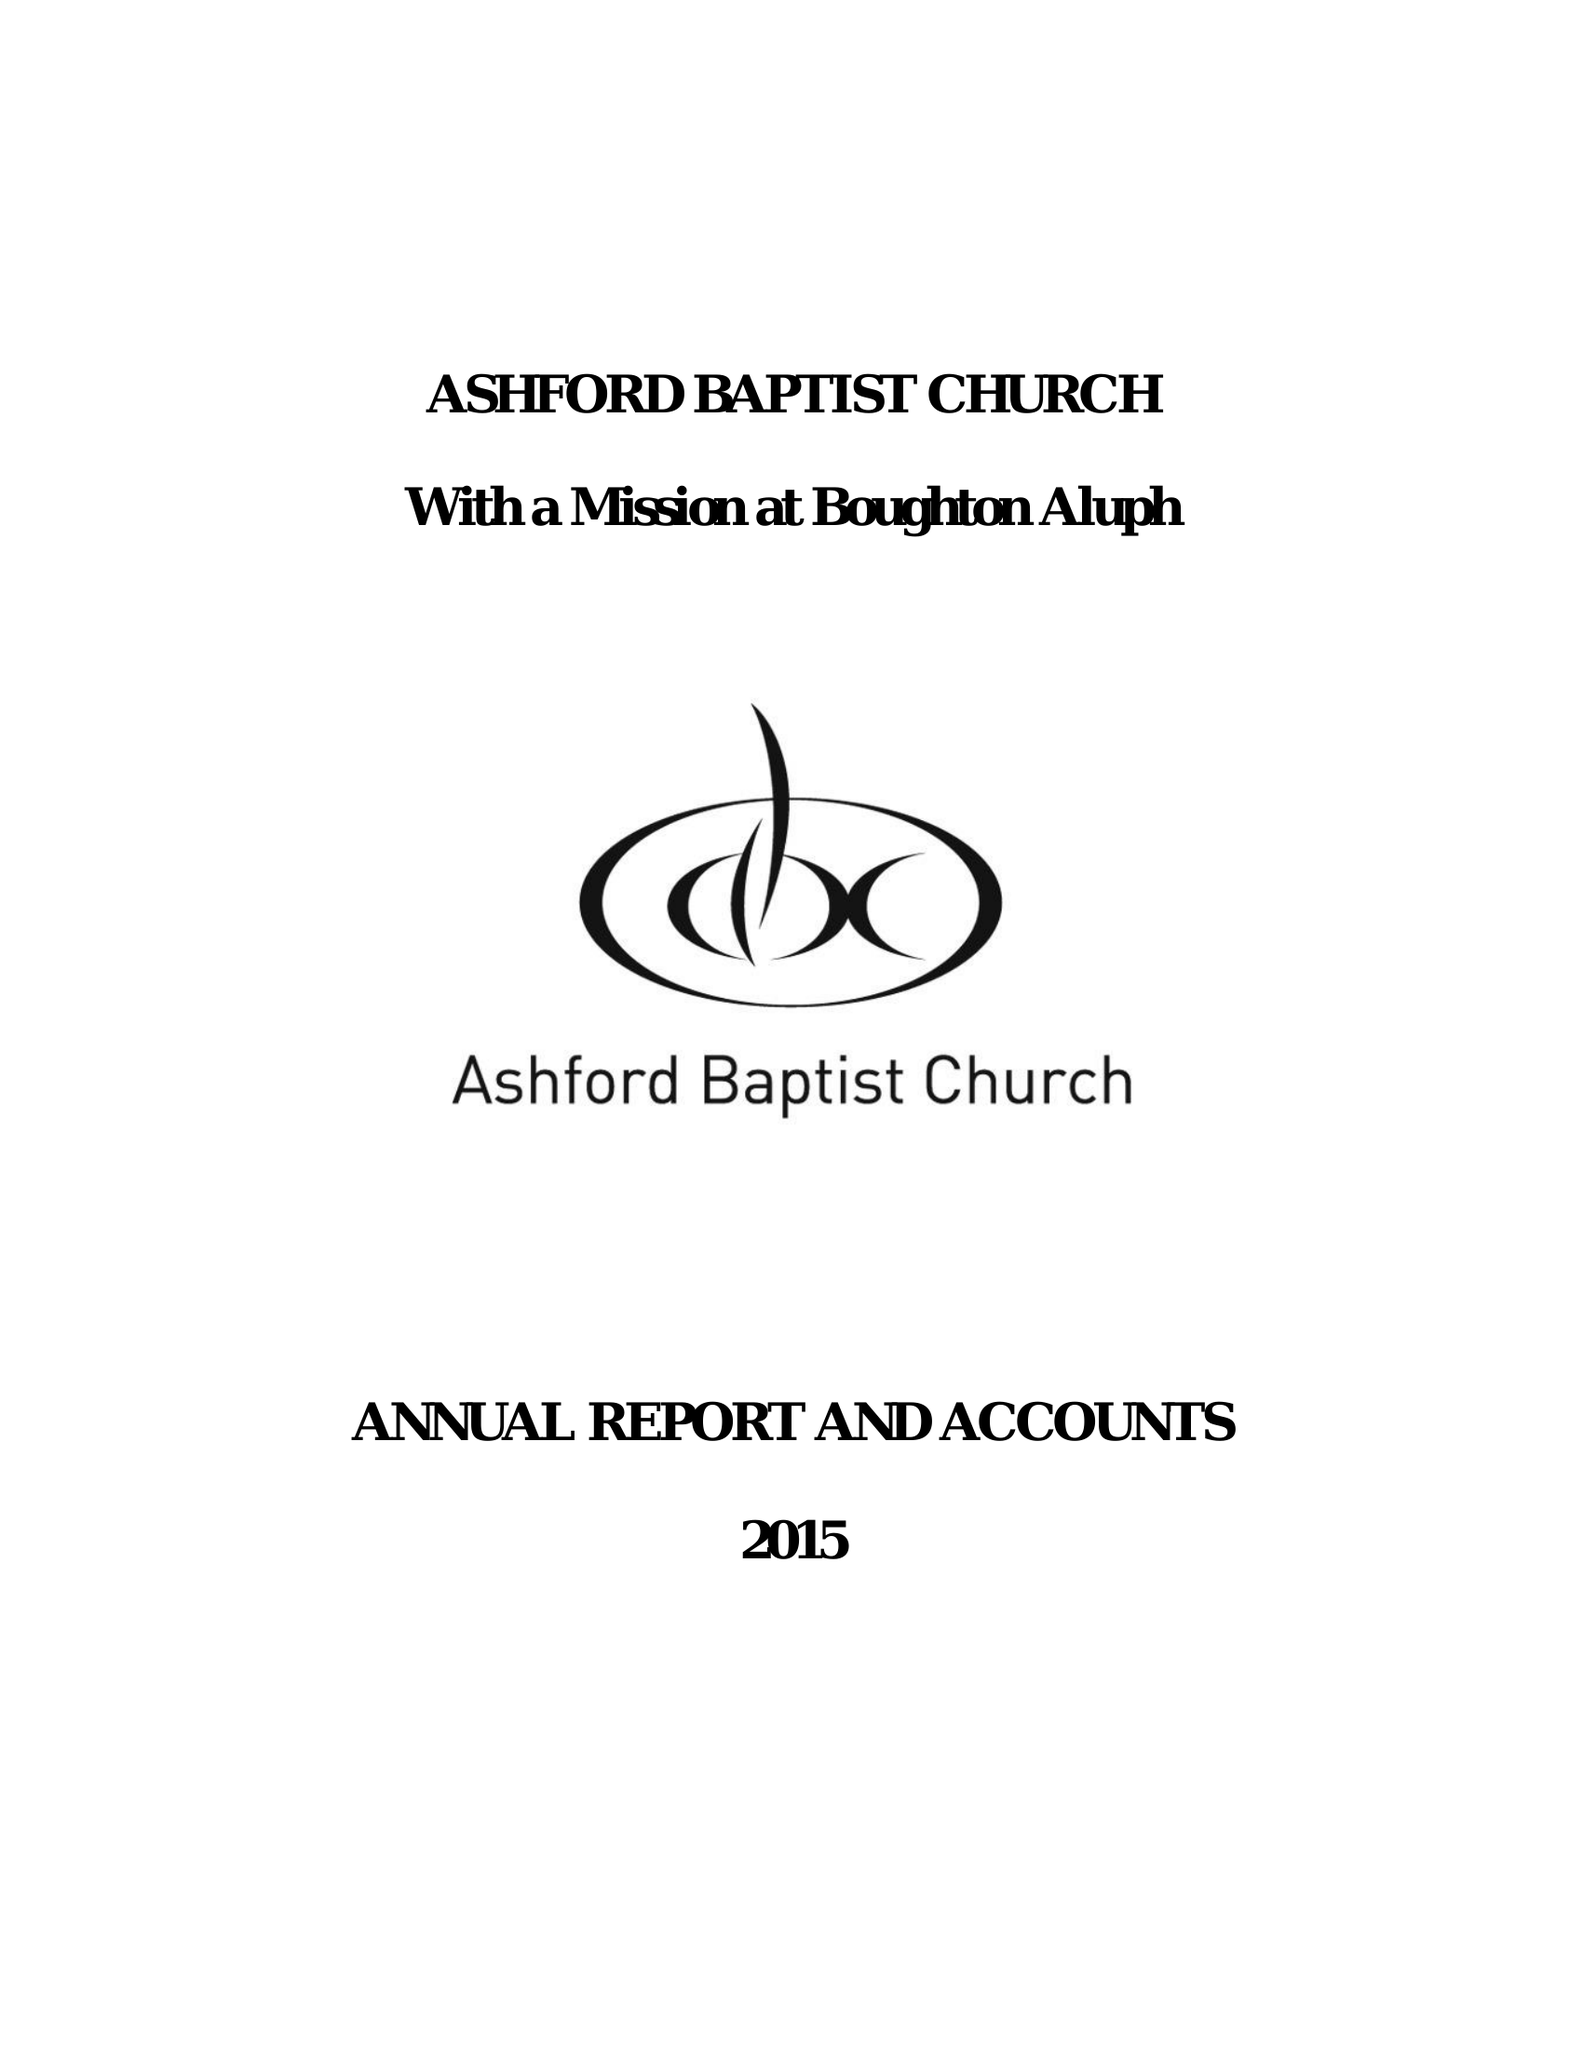What is the value for the charity_number?
Answer the question using a single word or phrase. 1130593 